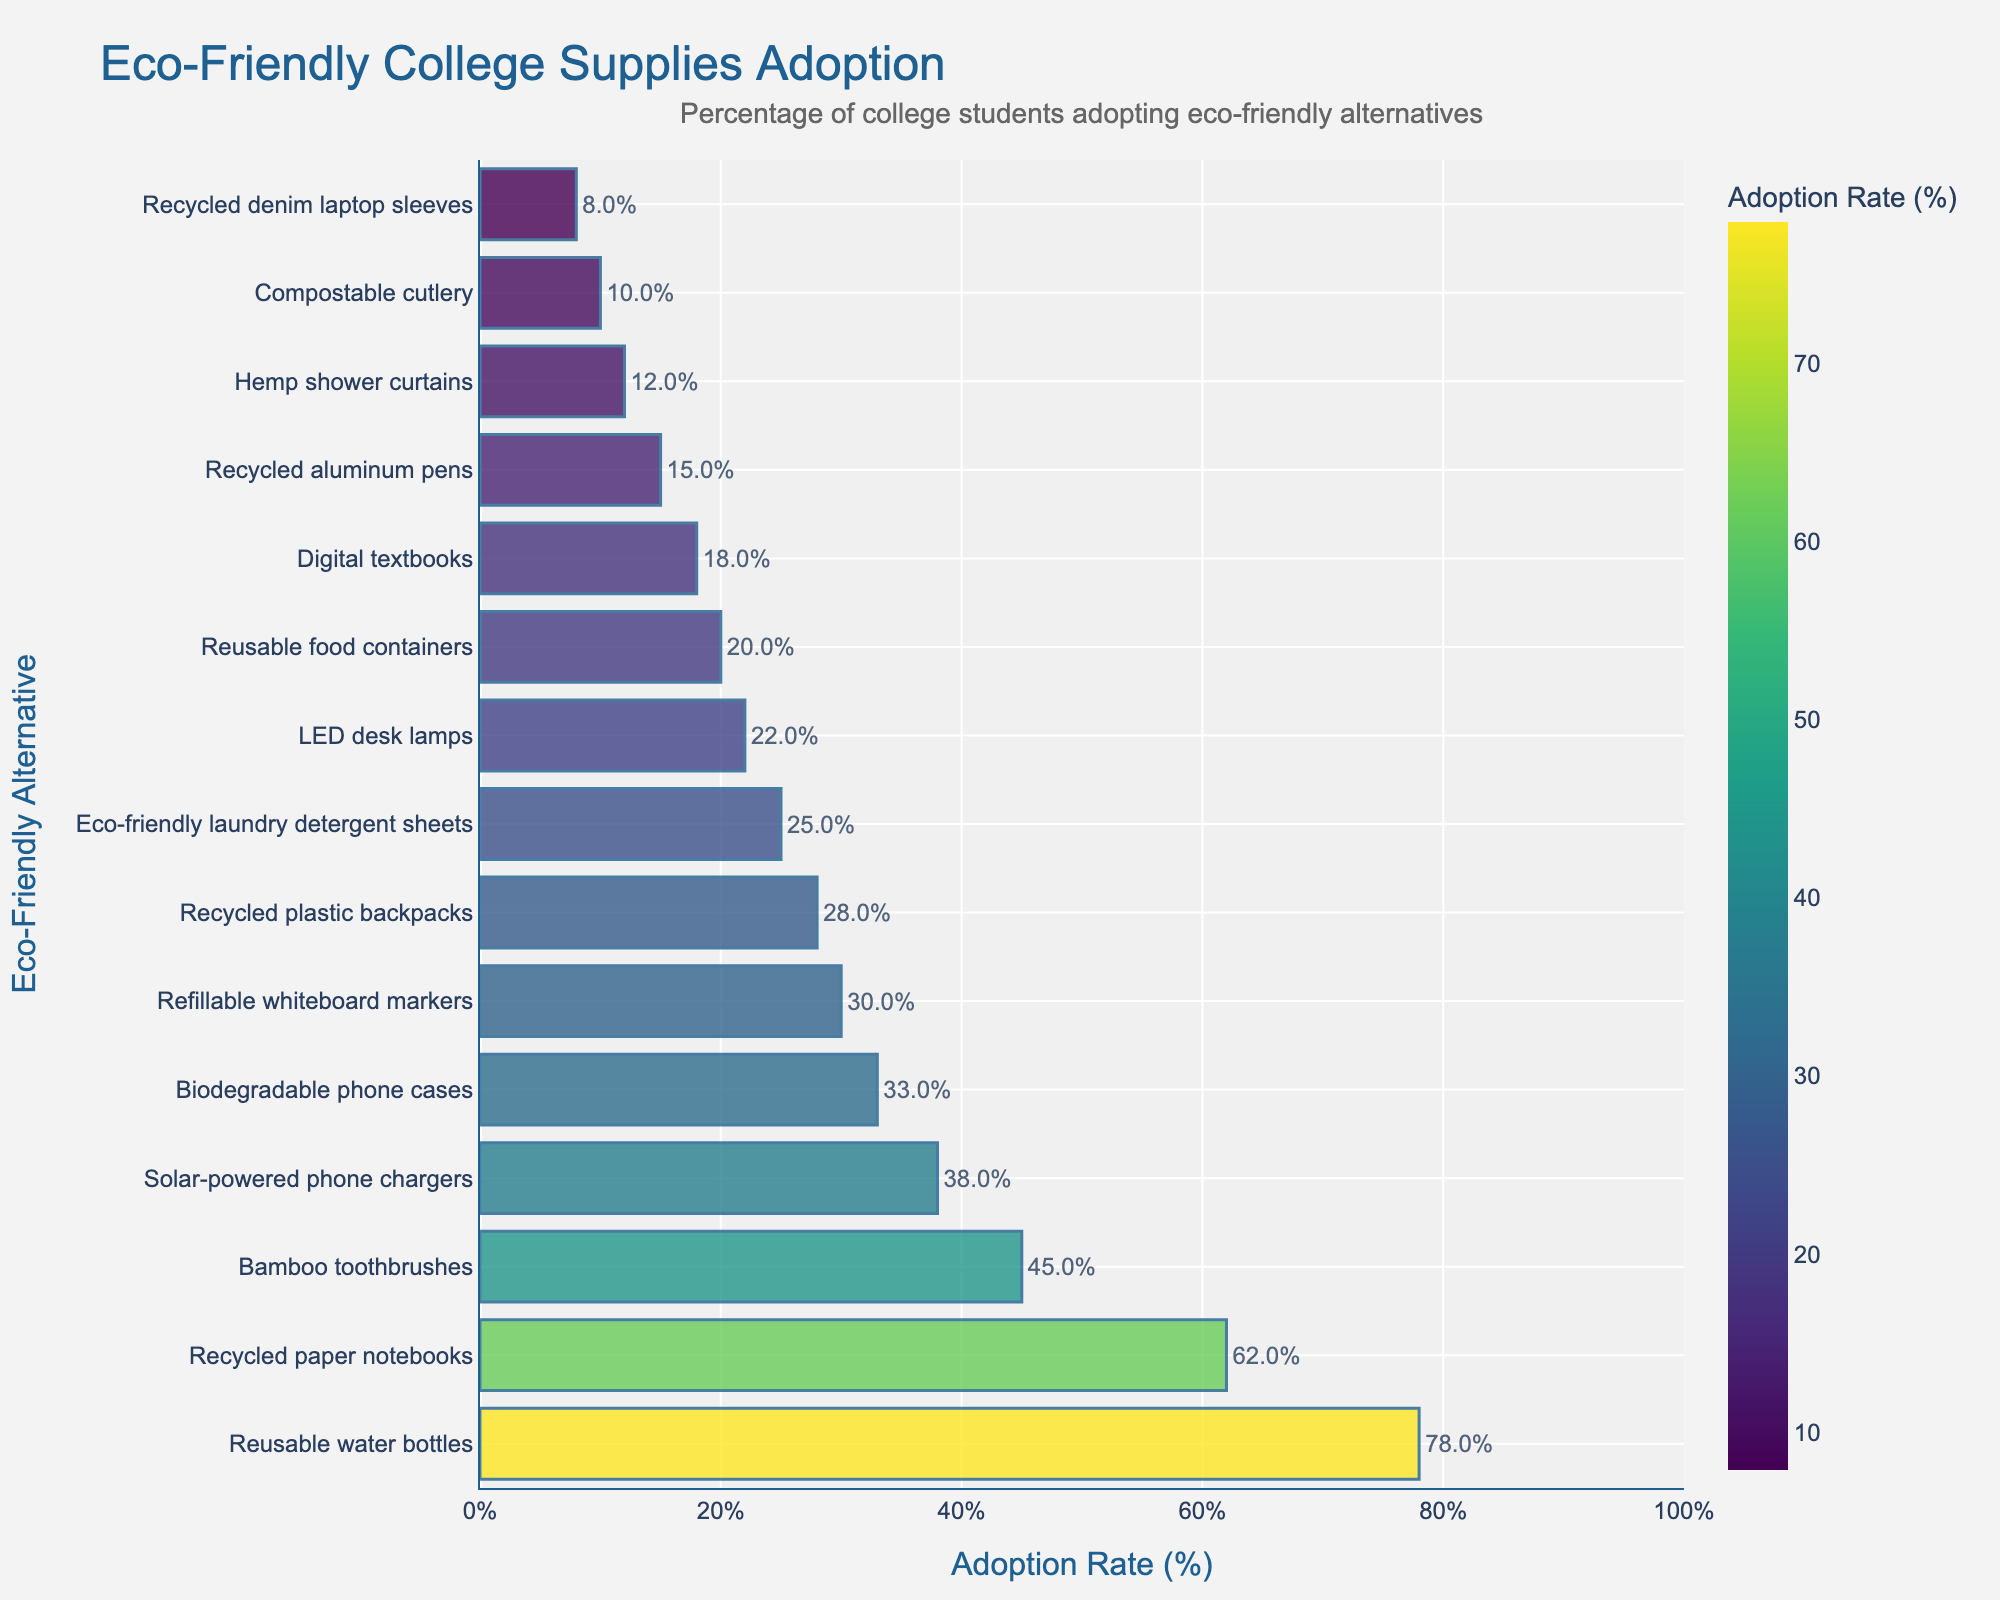Which eco-friendly product has the highest rate of adoption? Look for the bar with the longest length. The product with the longest bar represents the highest adoption rate.
Answer: Reusable water bottles Which eco-friendly product is adopted by the least percentage of college students? Look for the bar with the shortest length. The product with the shortest bar represents the lowest adoption rate.
Answer: Recycled denim laptop sleeves How much higher is the adoption rate of reusable water bottles compared to LED desk lamps? Find the adoption rates of both products and calculate the difference. Reusable water bottles have a rate of 78%, and LED desk lamps have a rate of 22%. Subtract 22 from 78.
Answer: 56% Which is more popular, bamboo toothbrushes or eco-friendly laundry detergent sheets? Compare the length of the bars. Bamboo toothbrushes have an adoption rate of 45%, while eco-friendly laundry detergent sheets have a rate of 25%.
Answer: Bamboo toothbrushes What is the combined adoption rate of recycled paper notebooks and refillable whiteboard markers? Find the adoption rates of both products and add them together. Recycled paper notebooks have a rate of 62%, and refillable whiteboard markers have a rate of 30%.
Answer: 92% Are solar-powered phone chargers adopted by more than a third of the students? Examine if the adoption rate for solar-powered phone chargers (38%) is higher than 33.33%.
Answer: Yes What is the average adoption rate of the three least popular products? Identify the three products with the lowest adoption rates (recycled denim laptop sleeves, compostable cutlery, hemp shower curtains) and calculate their average. The rates are 8%, 10%, and 12%. The average is (8 + 10 + 12) / 3.
Answer: 10% Is the adoption rate of biodegradable phone cases higher than that of digital textbooks? Compare the two adoption rates. Biodegradable phone cases have a rate of 33%, and digital textbooks have a rate of 18%.
Answer: Yes How does the adoption of eco-friendly items in the top five compare to those in the bottom five? Sum the adoption rates of the top five items (78%, 62%, 45%, 38%, 33%) and the bottom five items (20%, 18%, 15%, 12%, 10%). Compare the total or average rates.
Answer: Top five: 256%, Bottom five: 75% What percentage of students use recycled plastic backpacks compared to recyclable aluminum pens? Look at the adoption rates of both products. Recycled plastic backpacks have a rate of 28%, while recycled aluminum pens have a rate of 15%.
Answer: 28% vs 15% 